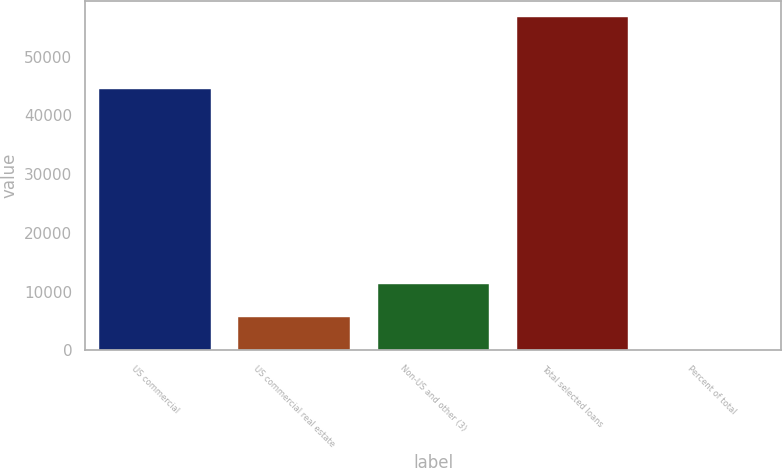Convert chart. <chart><loc_0><loc_0><loc_500><loc_500><bar_chart><fcel>US commercial<fcel>US commercial real estate<fcel>Non-US and other (3)<fcel>Total selected loans<fcel>Percent of total<nl><fcel>44424<fcel>5678.5<fcel>11344<fcel>56668<fcel>13<nl></chart> 